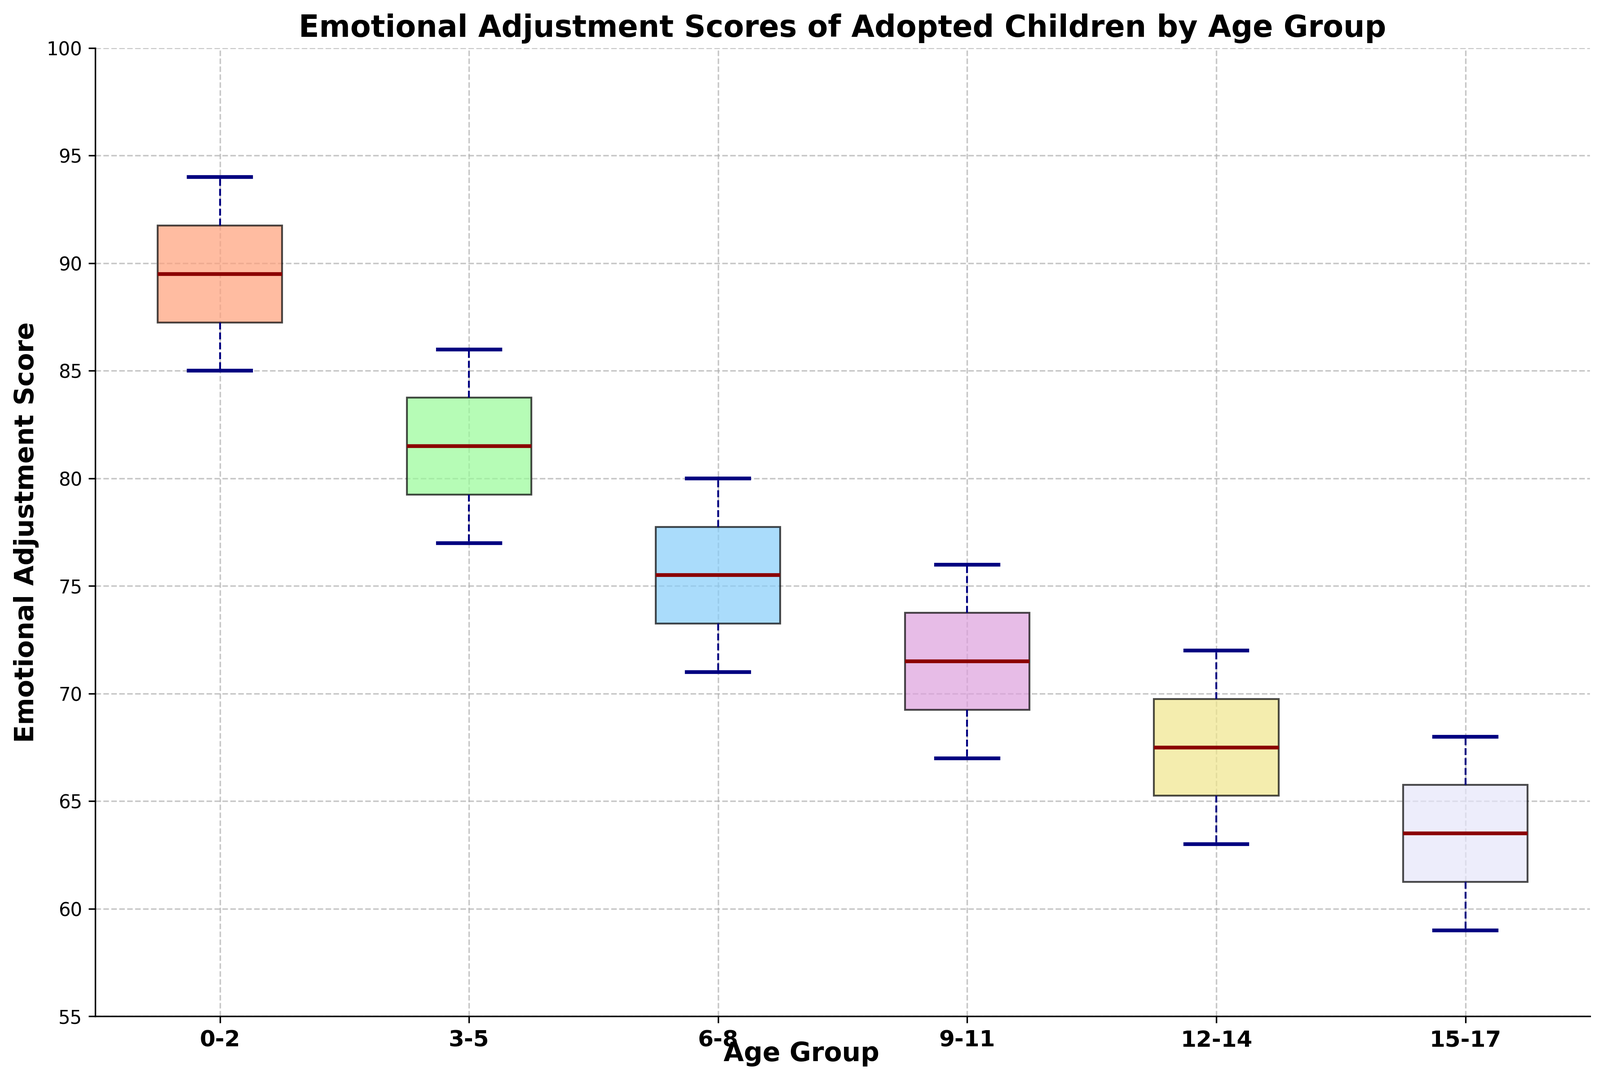What is the age group with the highest median emotional adjustment score? Look at the line inside each box, which represents the median. Compare the positions of these lines across all age groups. The highest median line is for the 0-2 age group.
Answer: 0-2 Which age group has the widest range of emotional adjustment scores? The range is the distance between the top and bottom whiskers. By comparing these distances, the age group 15-17 has the widest range.
Answer: 15-17 Is there an age group where the minimum emotional adjustment score is higher than the median score of another age group? Compare the lowest whisker of each age group with the median lines of other age groups. The minimum score for 0-2 is 85, which is higher than the median scores of 3-5, 6-8, 9-11, 12-14, and 15-17.
Answer: Yes Comparing the third quartile (the top of the box) across different age groups, which age group has the lowest third quartile? Look at the top of the boxes and find which one is the lowest. The 15-17 age group has the lowest third quartile.
Answer: 15-17 Are the emotional adjustment scores of the age groups 9-11 and 12-14 similar or different? How? Compare the positions and ranges of the boxes and whiskers of these two age groups. Both have overlapping ranges but different medians and interquartile ranges, with 12-14 being slightly lower.
Answer: Different For the age group 6-8, what is the range between the first and third quartiles? The range between the first and third quartiles is the length of the box. Estimate by looking at the ends of the box. The first quartile is around 73 and the third is around 77. Subtract the first quartile value from the third quartile value: 77 - 73 = 4.
Answer: 4 Which age group shows the least variability in emotional adjustment scores, based on the height of the whiskers and the box? The variability is smallest where the box and whiskers together are shortest. The 0-2 age group shows the least variability.
Answer: 0-2 What is the median emotional adjustment score for the age group 3-5? Find the line inside the box for 3-5; this represents the median score. For 3-5, it looks like the median score is around 81.
Answer: 81 Between the youngest (0-2) and oldest (15-17) age groups, which group has the higher third quartile and by how much? Look at the top of the boxes (third quartile) for 0-2 and 15-17. The third quartile for 0-2 is about 93, and for 15-17, it's about 66. Subtract 66 from 93: 93 - 66 = 27.
Answer: 0-2 by 27 Is the median score higher for the age group 6-8 or 12-14? Compare the line inside the box for 6-8 with that of 12-14. The median for 6-8 is higher.
Answer: 6-8 